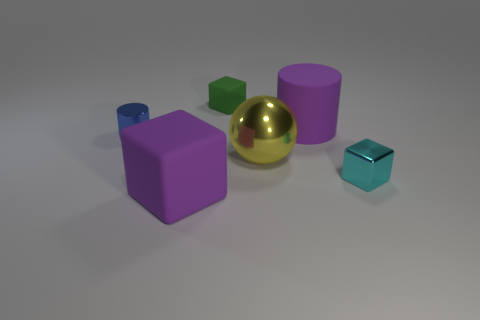Are there fewer large rubber cubes than small brown metal blocks?
Your answer should be very brief. No. What shape is the small blue thing that is made of the same material as the cyan thing?
Offer a terse response. Cylinder. Are there any tiny cyan metallic things behind the purple matte cylinder?
Offer a terse response. No. Is the number of purple things in front of the big block less than the number of small cyan objects?
Offer a terse response. Yes. What material is the tiny green cube?
Your response must be concise. Rubber. The tiny shiny cylinder is what color?
Your answer should be compact. Blue. There is a object that is behind the ball and left of the small rubber cube; what color is it?
Ensure brevity in your answer.  Blue. Are the blue thing and the big purple thing that is behind the big purple block made of the same material?
Ensure brevity in your answer.  No. There is a matte block in front of the small shiny thing to the right of the big purple matte cylinder; what is its size?
Offer a very short reply. Large. Is there anything else that is the same color as the tiny rubber object?
Offer a very short reply. No. 